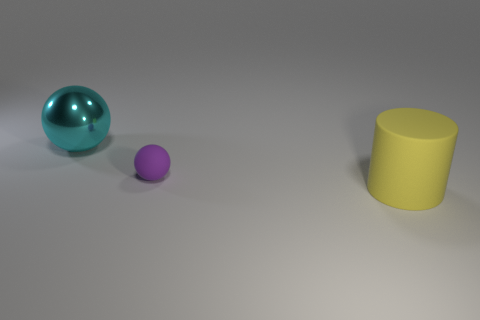Is the small purple thing the same shape as the yellow matte object?
Your answer should be compact. No. Is there anything else of the same color as the small thing?
Make the answer very short. No. The thing that is both behind the big matte cylinder and in front of the big ball has what shape?
Your response must be concise. Sphere. Are there an equal number of balls that are on the right side of the large shiny thing and cyan shiny balls that are in front of the tiny sphere?
Give a very brief answer. No. How many balls are either big purple things or yellow things?
Provide a succinct answer. 0. What number of other tiny balls are made of the same material as the cyan sphere?
Your answer should be compact. 0. What material is the object that is both behind the yellow matte cylinder and in front of the large sphere?
Offer a very short reply. Rubber. There is a large thing behind the large yellow cylinder; what shape is it?
Provide a short and direct response. Sphere. There is a big thing in front of the ball on the left side of the small rubber thing; what shape is it?
Offer a very short reply. Cylinder. Are there any large yellow rubber things that have the same shape as the purple matte object?
Keep it short and to the point. No. 